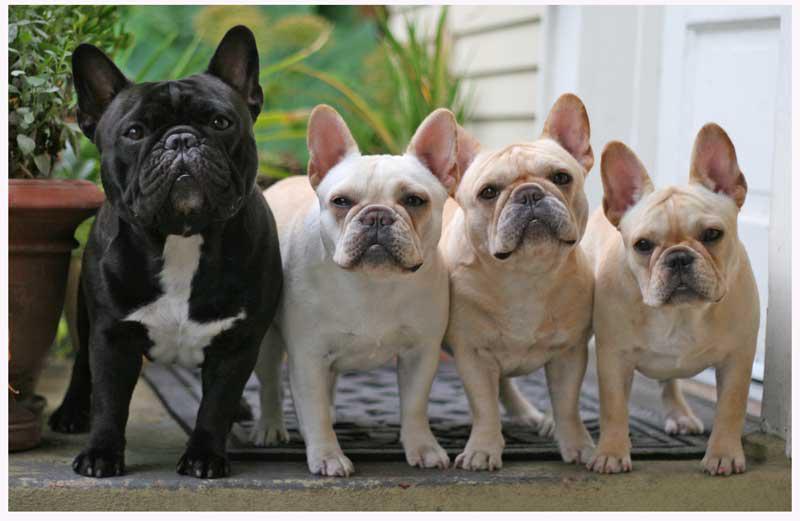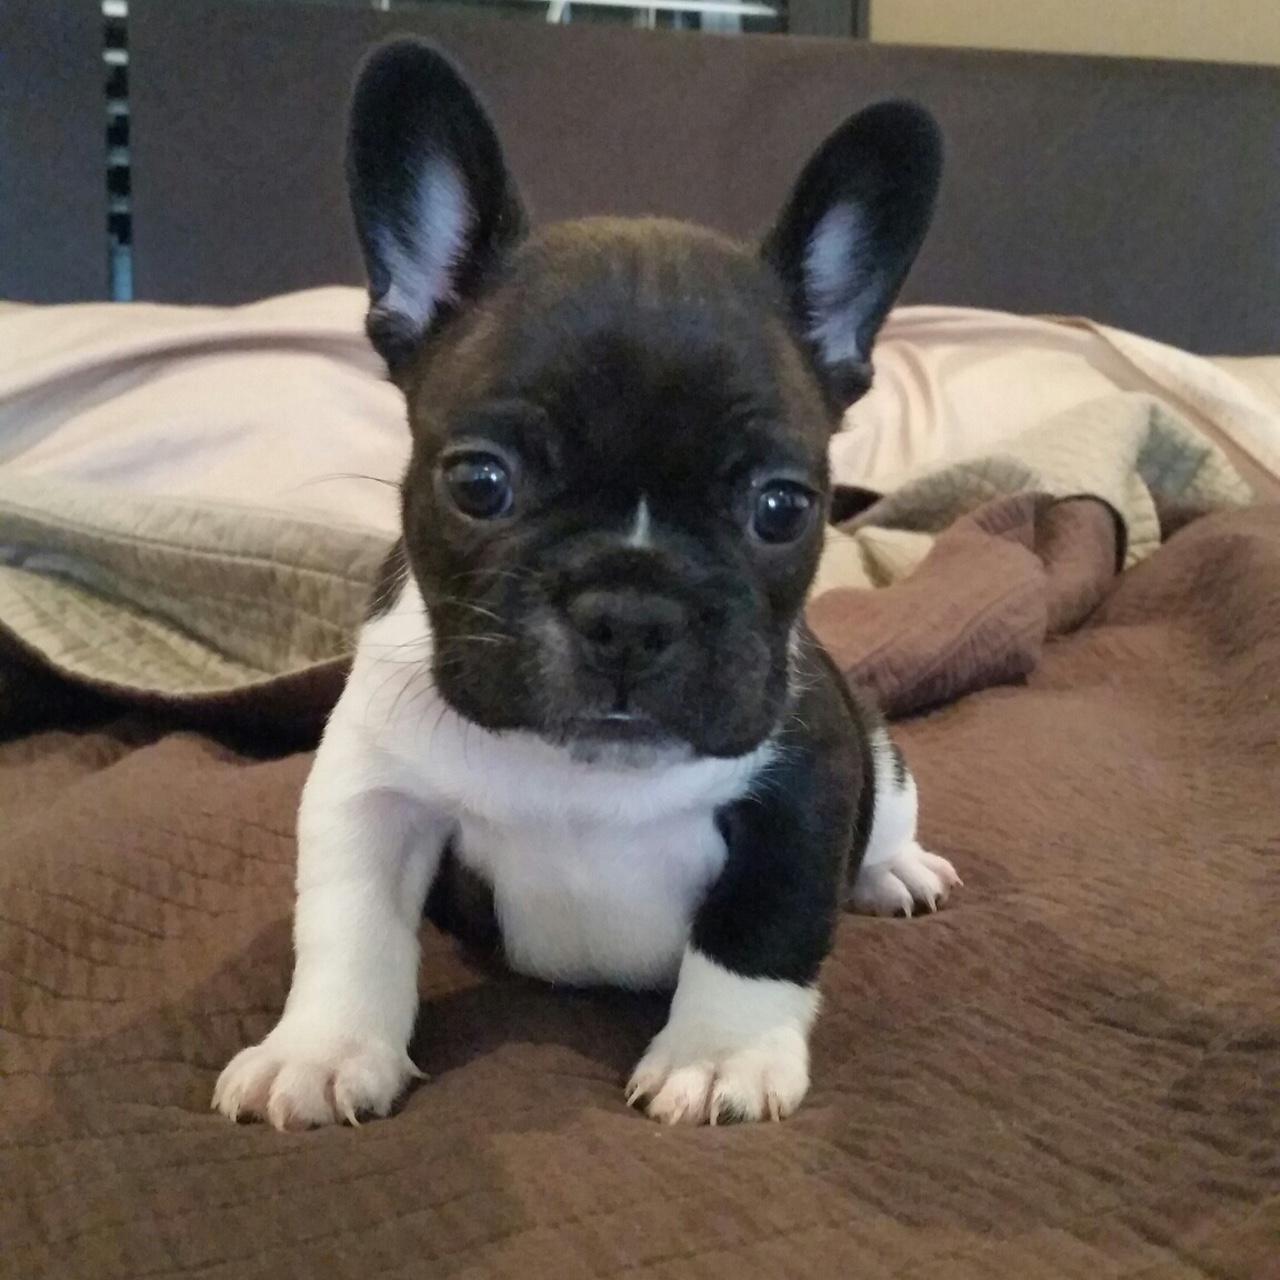The first image is the image on the left, the second image is the image on the right. Analyze the images presented: Is the assertion "An image shows a row of at least 8 dogs on a cement step." valid? Answer yes or no. No. The first image is the image on the left, the second image is the image on the right. Analyze the images presented: Is the assertion "There are no more than five dogs" valid? Answer yes or no. Yes. 